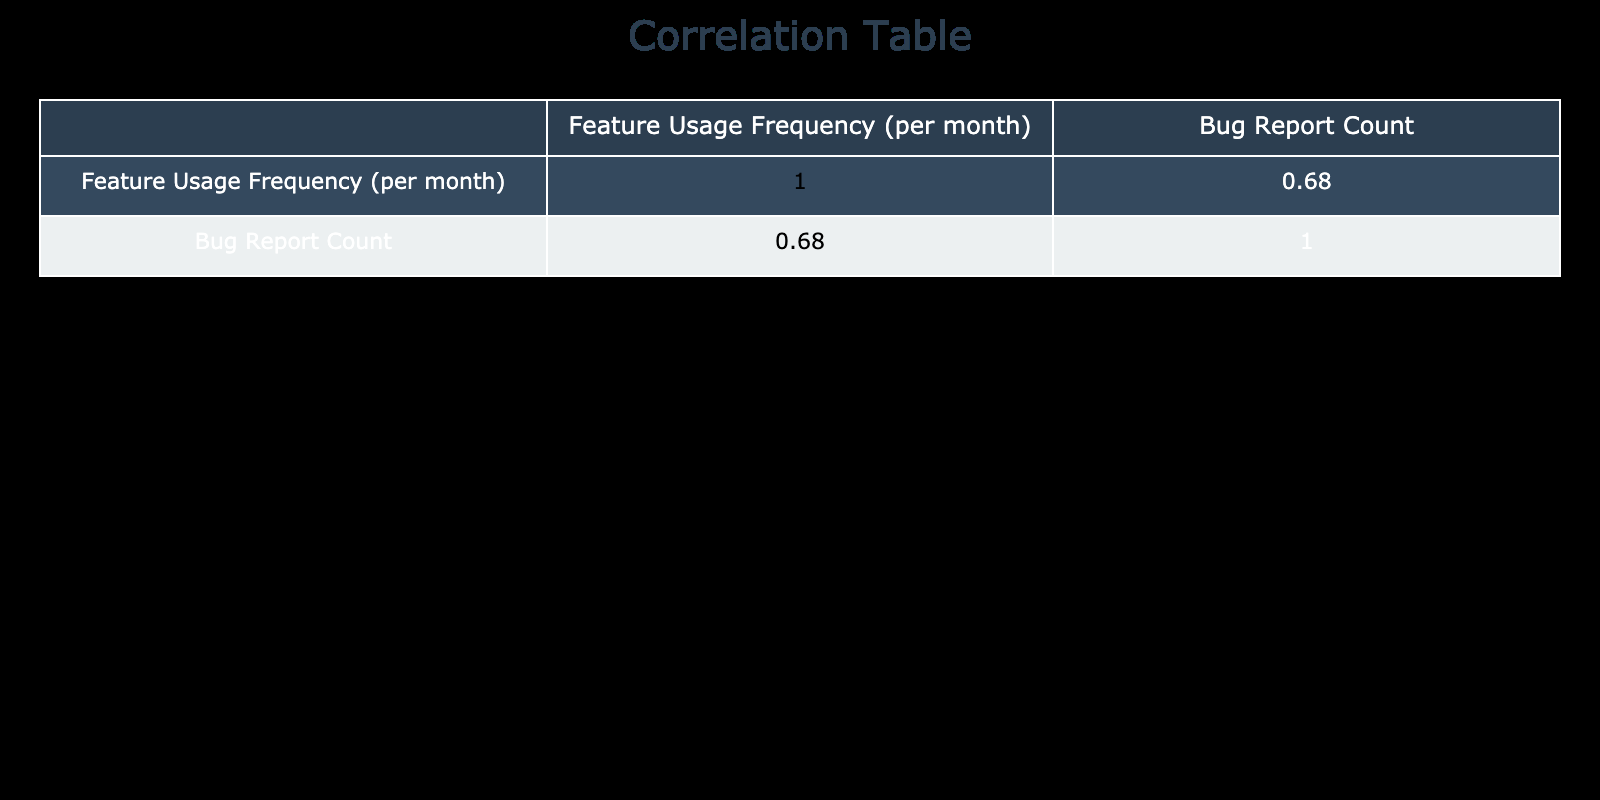What is the bug report count for the Search Functionality feature? The bug report count is listed directly in the table for the Search Functionality feature. It shows a count of 35.
Answer: 35 What feature has the highest usage frequency? The usage frequencies of all features are compared, and the feature with the highest frequency is identified as Search Functionality with 1300.
Answer: Search Functionality What is the average bug report count across all features? To find the average bug report count, sum the individual counts: 15 + 25 + 10 + 5 + 20 + 30 + 35 + 12 + 8 + 7 + 2 + 20 + 22 + 14 + 18 =  1 + 25 + 10 + 5 + 20 + 30 + 35 + 12 + 8 + 7 + 2 + 20 + 22 + 14 + 18 =  7 + 20 + 30 + 35 + 12 + 8 + 7 + 2 + 20 + 22 + 14 + 18 =  125 / 15 (there are 15 features) = approximately 12.5.
Answer: 12.5 Is there a feature with a usage frequency lower than 300 that also has a bug report count? Yes, by reviewing the table it is noted that Multi-language Support has a usage frequency of 300 but still has a bug report count of 8.
Answer: Yes Which feature has the lowest bug report count and what is that count? The feature with the lowest bug report count is Backup and Restore, as seen in the table where its bug count is reported as 2.
Answer: Backup and Restore, 2 What is the total bug report count for features that have a usage frequency greater than 700? To answer this, first identify the features with usage frequencies greater than 700: User Authentication (15), Payment Processing (25), Real-time Notifications (30), Search Functionality (35), and Account Management (20). Next, sum the corresponding bug report counts: 15 + 25 + 30 + 35 + 20 = 125.
Answer: 125 Are there any features with a usage frequency of less than 400 that also experience more than 10 bug reports? Yes, by examining the table, both Dashboard Customization (12 bug reports) and Interactive Data Visualizations (14 bug reports) are features where the usage frequency is below 400 but the bug report count exceeds 10.
Answer: Yes What is the difference in bug report counts between the most used feature and the least used feature? The most used feature is Search Functionality with a bug report count of 35 and the least used feature is Backup and Restore with a bug report count of 2. The difference is calculated as 35 - 2 = 33.
Answer: 33 What percentage of features have bug report counts that are less than 10? First, count the total number of features, which is 15. Then identify the features with bug report counts less than 10. These include Data Export (5), Multi-language Support (8), and API Integration (7), which totals to 3 features. The percentage is (3/15) * 100 = 20%.
Answer: 20% 